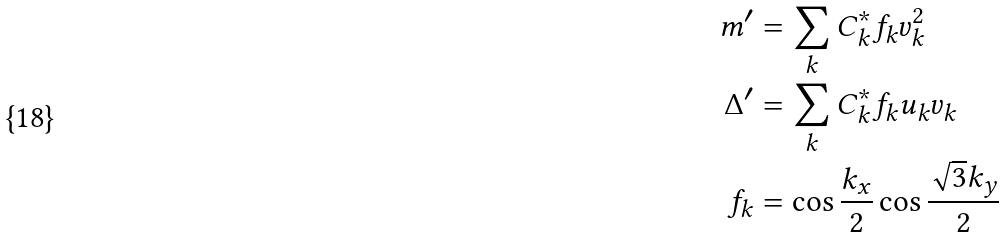<formula> <loc_0><loc_0><loc_500><loc_500>m ^ { \prime } & = \sum _ { k } { C _ { k } ^ { * } f _ { k } v _ { k } ^ { 2 } } \\ \Delta ^ { \prime } & = \sum _ { k } { C _ { k } ^ { * } f _ { k } u _ { k } v _ { k } } \\ f _ { k } & = \cos { \frac { k _ { x } } { 2 } } \cos { \frac { \sqrt { 3 } k _ { y } } { 2 } }</formula> 